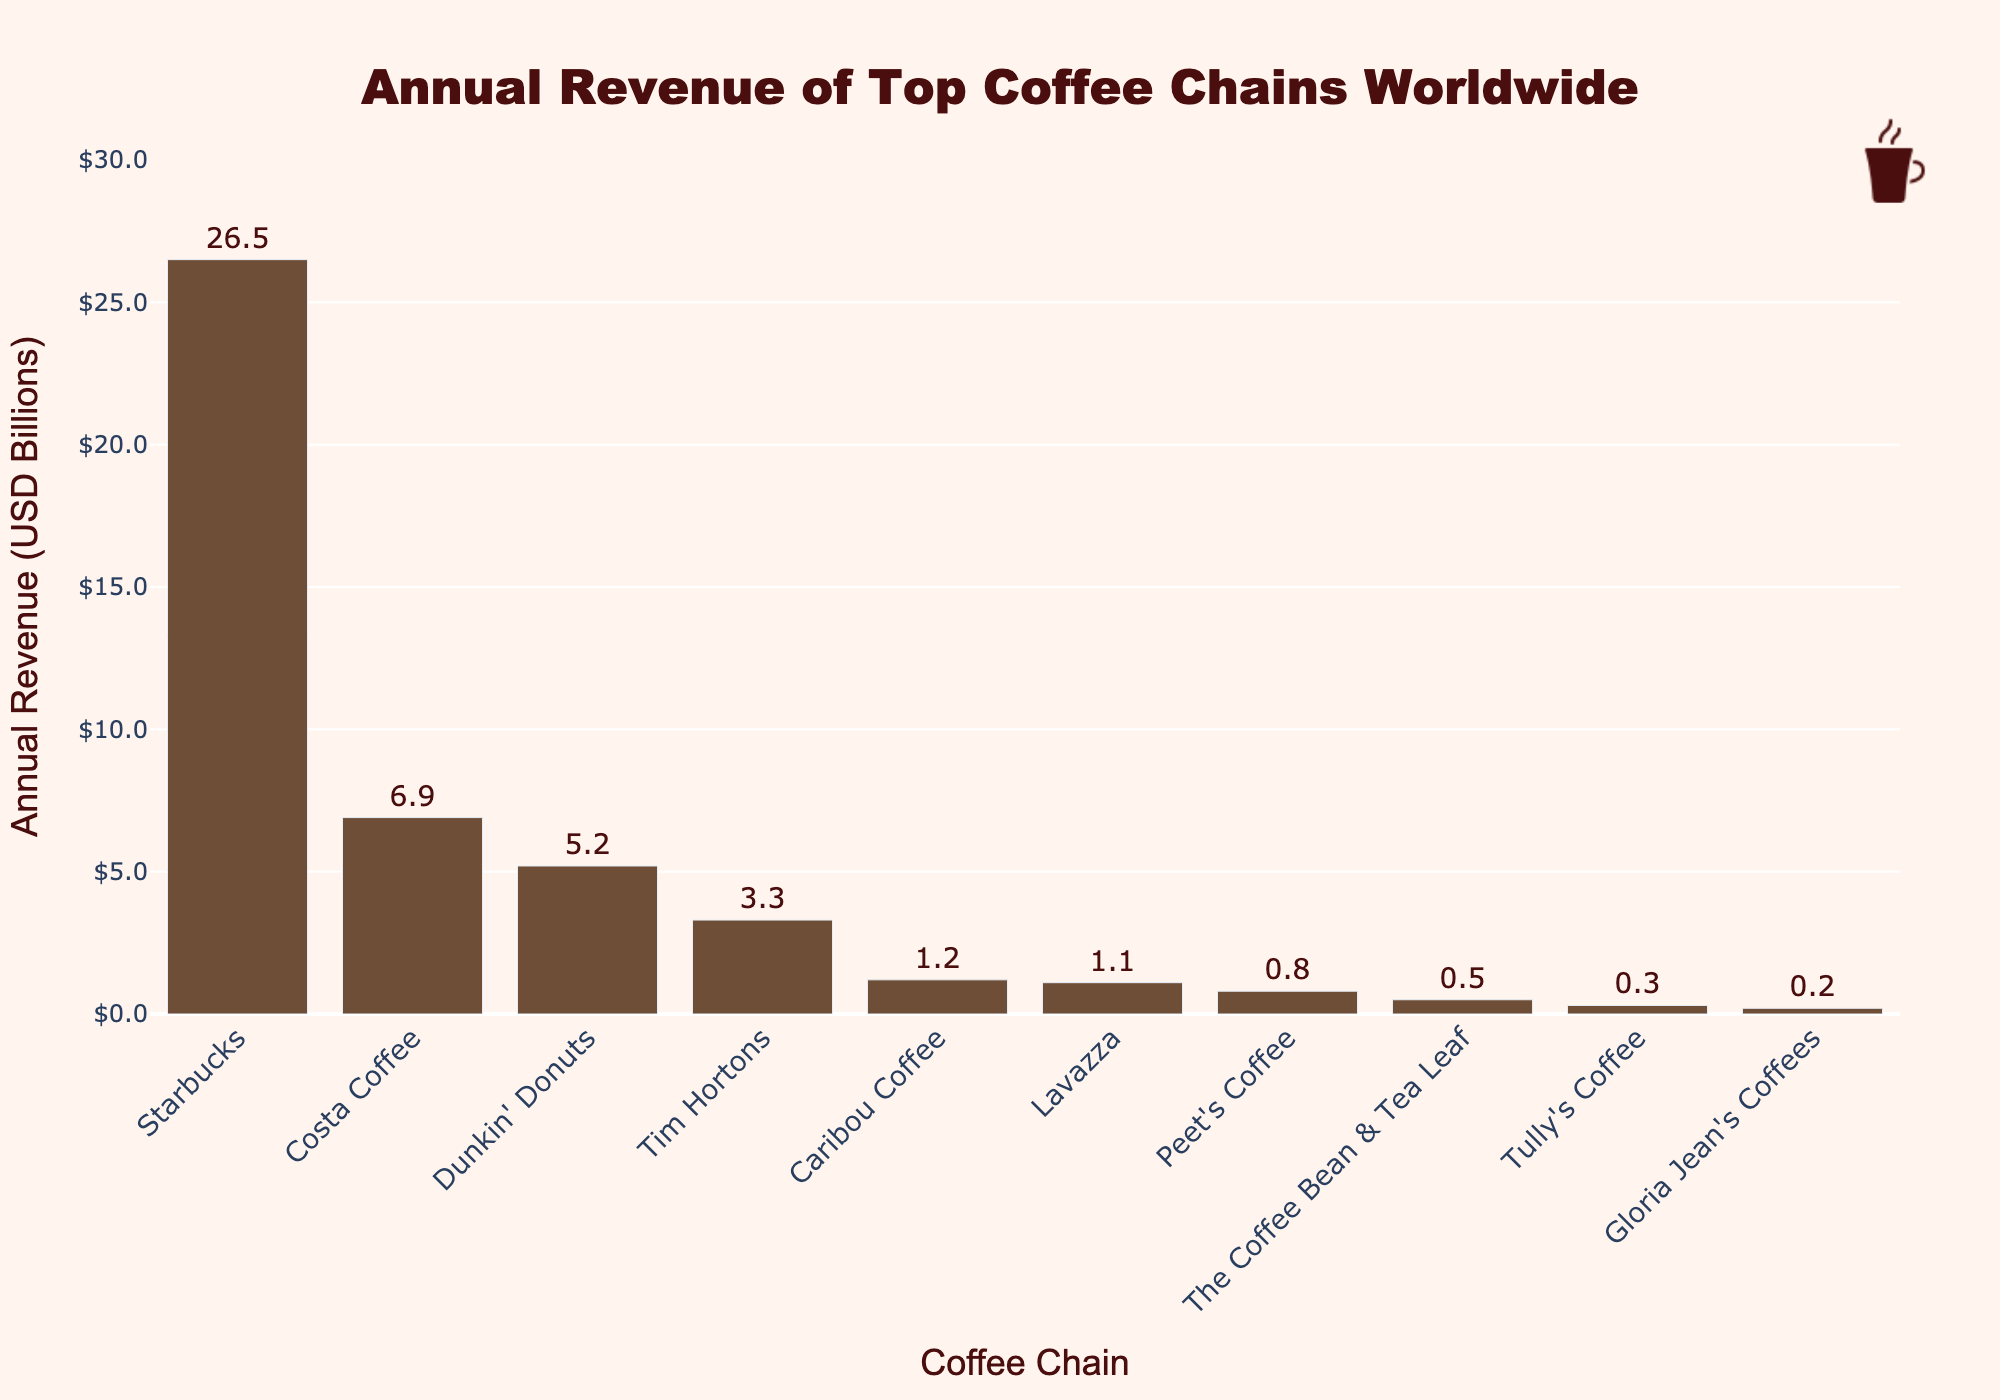what's the total annual revenue of Starbucks and Costa Coffee combined? Sum the annual revenues of Starbucks ($26.5 billion) and Costa Coffee ($6.9 billion) by adding 26.5 + 6.9, which equals 33.4.
Answer: 33.4 what's the annual revenue difference between Dunkin' Donuts and Tim Hortons? Subtract the annual revenue of Tim Hortons ($3.3 billion) from Dunkin' Donuts ($5.2 billion) by calculating 5.2 - 3.3, which equals 1.9.
Answer: 1.9 which coffee chain has the highest annual revenue? Identify the coffee chain with the tallest bar in the chart - Starbucks with an annual revenue of $26.5 billion.
Answer: Starbucks how does the annual revenue of Caribou Coffee compare to Lavazza? Compare the heights of the bars for Caribou Coffee ($1.2 billion) and Lavazza ($1.1 billion) visually. Caribou Coffee has a slightly higher bar, indicating a higher revenue.
Answer: Caribou Coffee what's the average annual revenue of the coffee chains in the chart? Add up all the annual revenues of the coffee chains: 26.5, 6.9, 5.2, 3.3, 1.2, 1.1, 0.8, 0.5, 0.3, 0.2. The sum is 45.0. Divide this by the number of coffee chains (10), yielding an average of 45.0 / 10 = 4.5.
Answer: 4.5 what's the median annual revenue of the coffee chains in the chart? Order the annual revenues: 0.2, 0.3, 0.5, 0.8, 1.1, 1.2, 3.3, 5.2, 6.9, 26.5. The median is the middle value, which is the average of the 5th and 6th values, (1.1 + 1.2) / 2 = 1.15.
Answer: 1.15 which coffee chains have an annual revenue less than $1 billion? Identify the coffee chains with bars shorter than $1 billion: Peet's Coffee, The Coffee Bean & Tea Leaf, Tully's Coffee, and Gloria Jean's Coffees.
Answer: Peet's Coffee, The Coffee Bean & Tea Leaf, Tully's Coffee, Gloria Jean's Coffees by how much does Starbucks annual revenue exceed the combined annual revenue of Tim Hortons and Dunkin' Donuts? First, sum the revenues of Tim Hortons ($3.3 billion) and Dunkin' Donuts ($5.2 billion), which is $8.5 billion. Subtract this from Starbucks' revenue: 26.5 - 8.5 = 18.0.
Answer: 18.0 which coffee chain ranks third in terms of annual revenue? Refer to the bars sorted in descending order by height. The third tallest bar belongs to Dunkin' Donuts with an annual revenue of $5.2 billion.
Answer: Dunkin' Donuts 